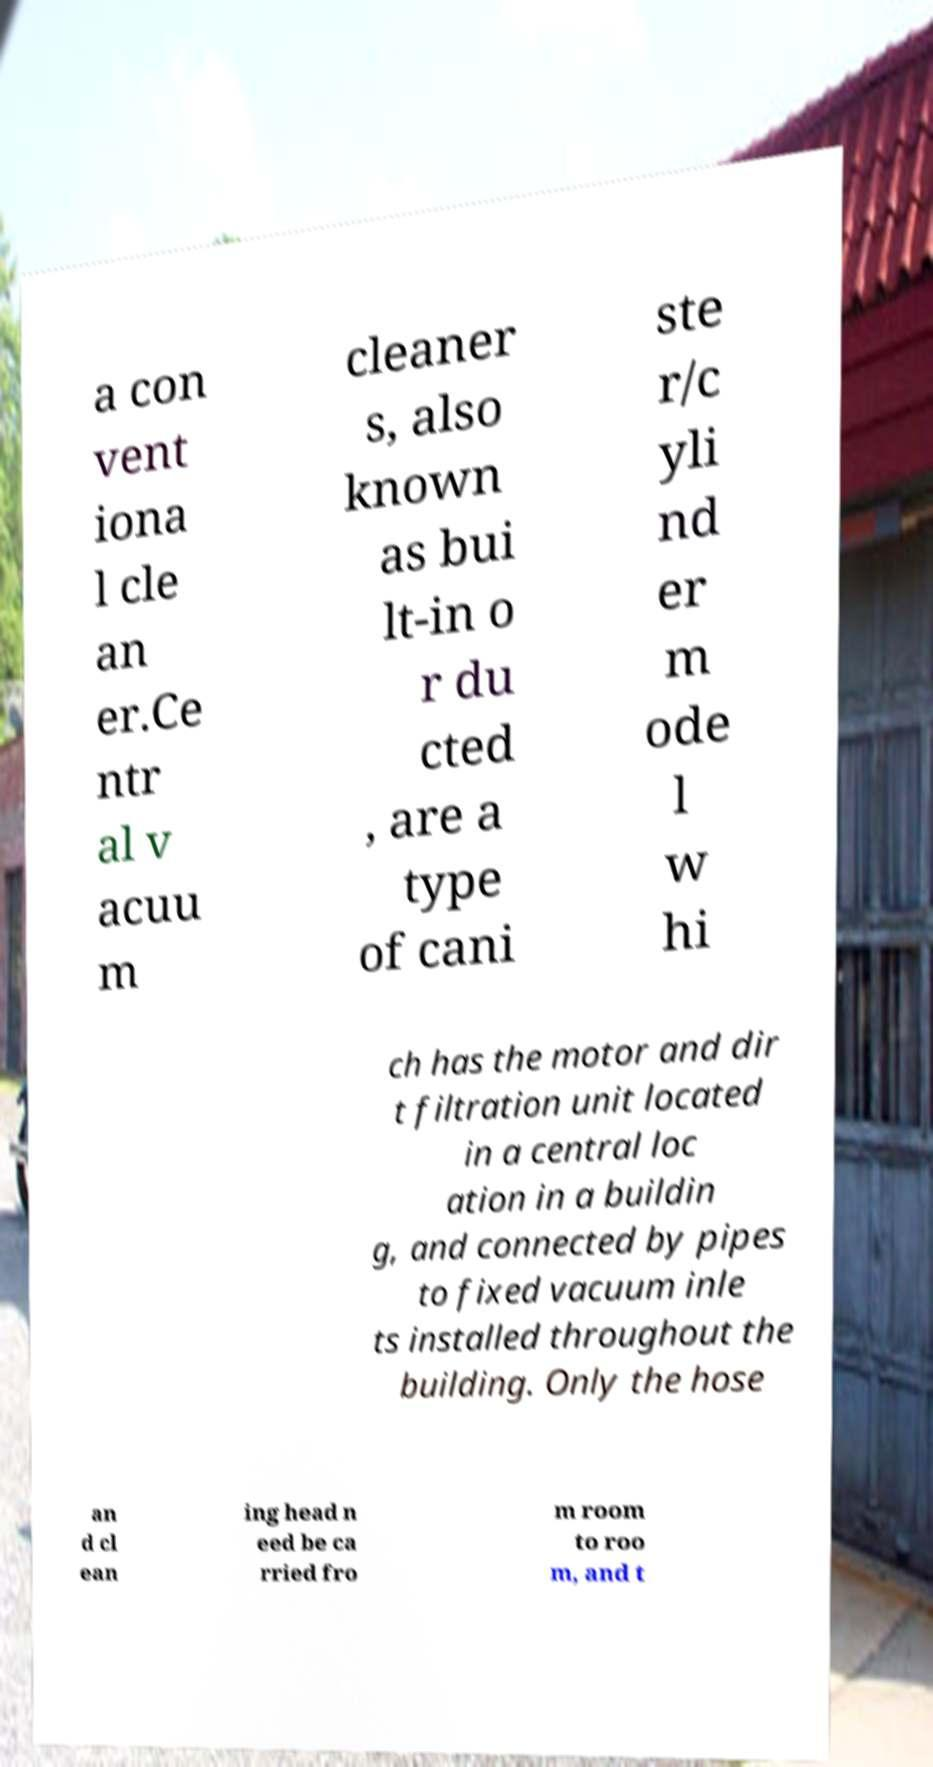Could you extract and type out the text from this image? a con vent iona l cle an er.Ce ntr al v acuu m cleaner s, also known as bui lt-in o r du cted , are a type of cani ste r/c yli nd er m ode l w hi ch has the motor and dir t filtration unit located in a central loc ation in a buildin g, and connected by pipes to fixed vacuum inle ts installed throughout the building. Only the hose an d cl ean ing head n eed be ca rried fro m room to roo m, and t 